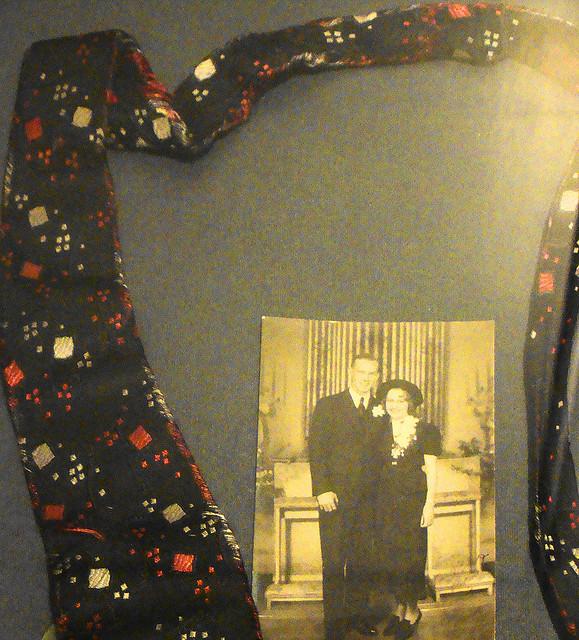What is surrounding the photo?
Give a very brief answer. Tie. Is the photo in color?
Be succinct. No. Is the photo framed?
Quick response, please. No. 